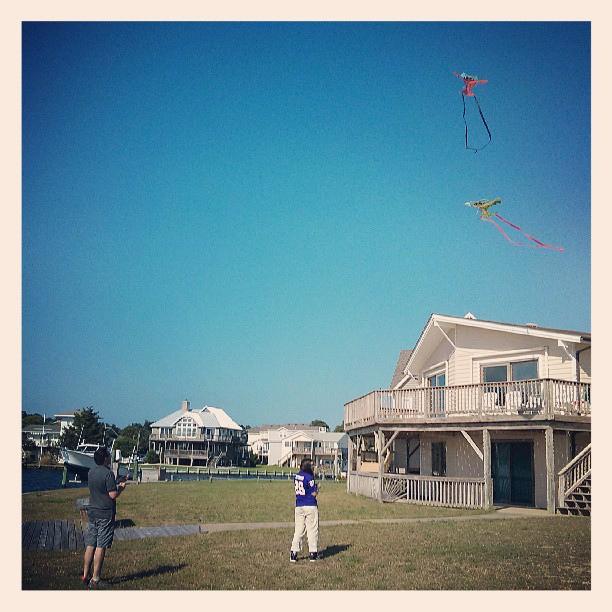Is it cloudy?
Write a very short answer. No. Is this a colorful photo?
Give a very brief answer. Yes. Is the man going to surf?
Short answer required. No. What are the weather conditions?
Give a very brief answer. Sunny. What is in the sky?
Concise answer only. Kites. Is the man staring at the sea?
Be succinct. No. Are they high in the mountains?
Concise answer only. No. What are the people doing?
Answer briefly. Flying kites. What is the kid playing with?
Short answer required. Kite. How is the sky looking like?
Answer briefly. Clear. How many tails does the kite have?
Short answer required. 2. Is there clouds in the sky?
Give a very brief answer. No. Is there a kite in the sky?
Short answer required. Yes. How many birds do you see in the air?
Keep it brief. 0. How many buildings are there?
Quick response, please. 4. Is it cloudy or sunny?
Give a very brief answer. Sunny. Are those wind turbines?
Keep it brief. No. Is the sky clear?
Short answer required. Yes. What is the person in the shadow holding?
Keep it brief. Kite. Are there any people in this picture?
Give a very brief answer. Yes. What print is it on the blue shirt?
Quick response, please. Numbers. How many people in the photo?
Answer briefly. 2. What color is the photo?
Short answer required. Blue and green. Is there snow on the ground?
Answer briefly. No. 